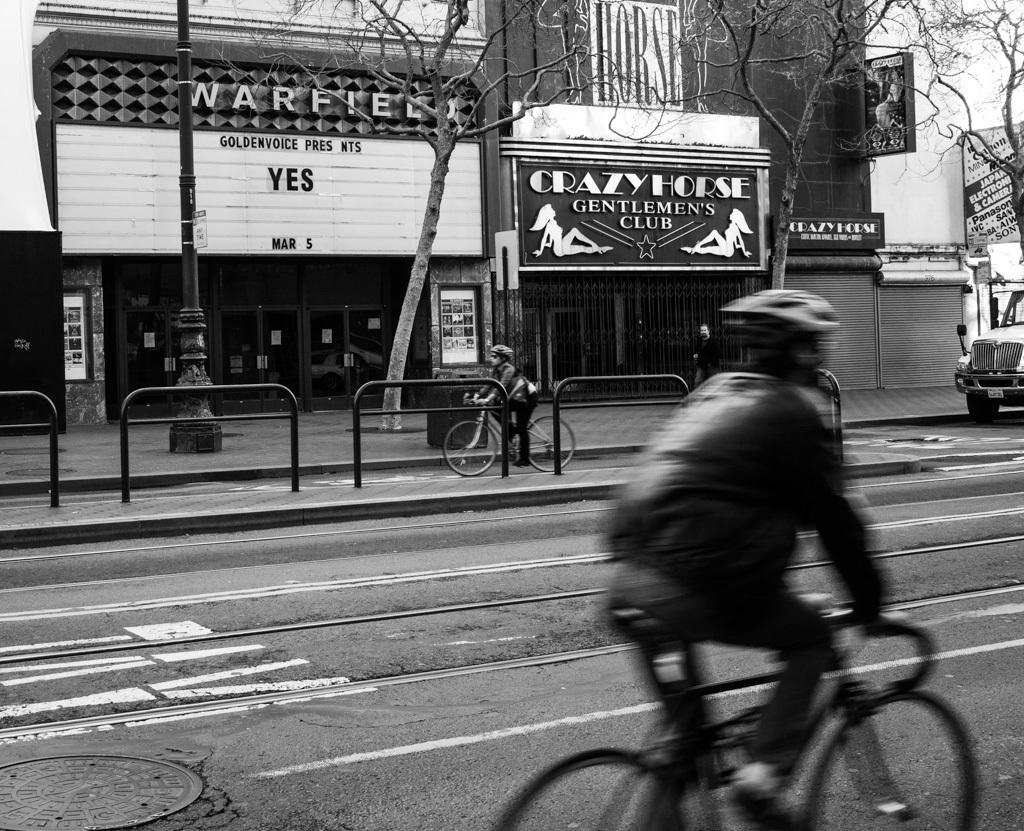Can you describe this image briefly? There is a man who is riding his bicycle on road and he is also wearing his helmet. We can see a person in middle who is riding his bicycle and he was also wearing glasses. We can see a person who is walking on foot path,there is a pole we can also see trees without any leaves. There is a vehicle on right side, we can see hoarding. In the background there is a building, doors and some board. 